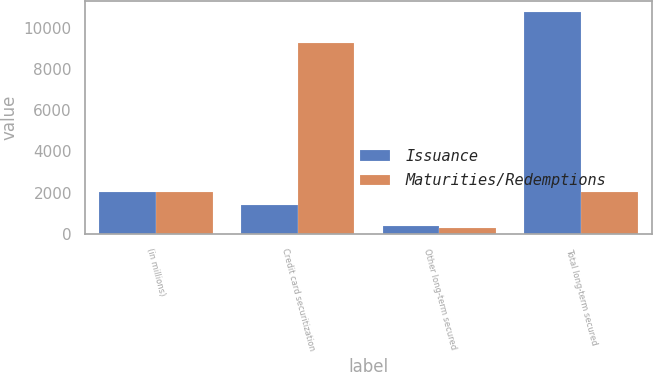Convert chart to OTSL. <chart><loc_0><loc_0><loc_500><loc_500><stacked_bar_chart><ecel><fcel>(in millions)<fcel>Credit card securitization<fcel>Other long-term secured<fcel>Total long-term secured<nl><fcel>Issuance<fcel>2018<fcel>1396<fcel>377<fcel>10773<nl><fcel>Maturities/Redemptions<fcel>2018<fcel>9250<fcel>289<fcel>2018<nl></chart> 